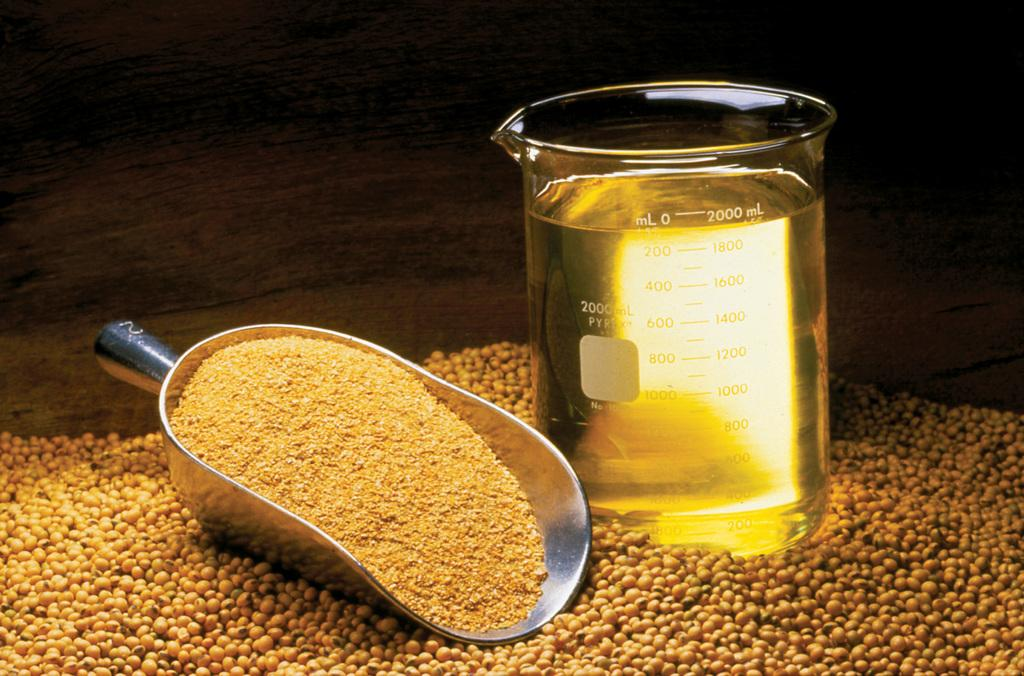<image>
Describe the image concisely. A metal scoop next to a beaker with 2000ml of liquid 